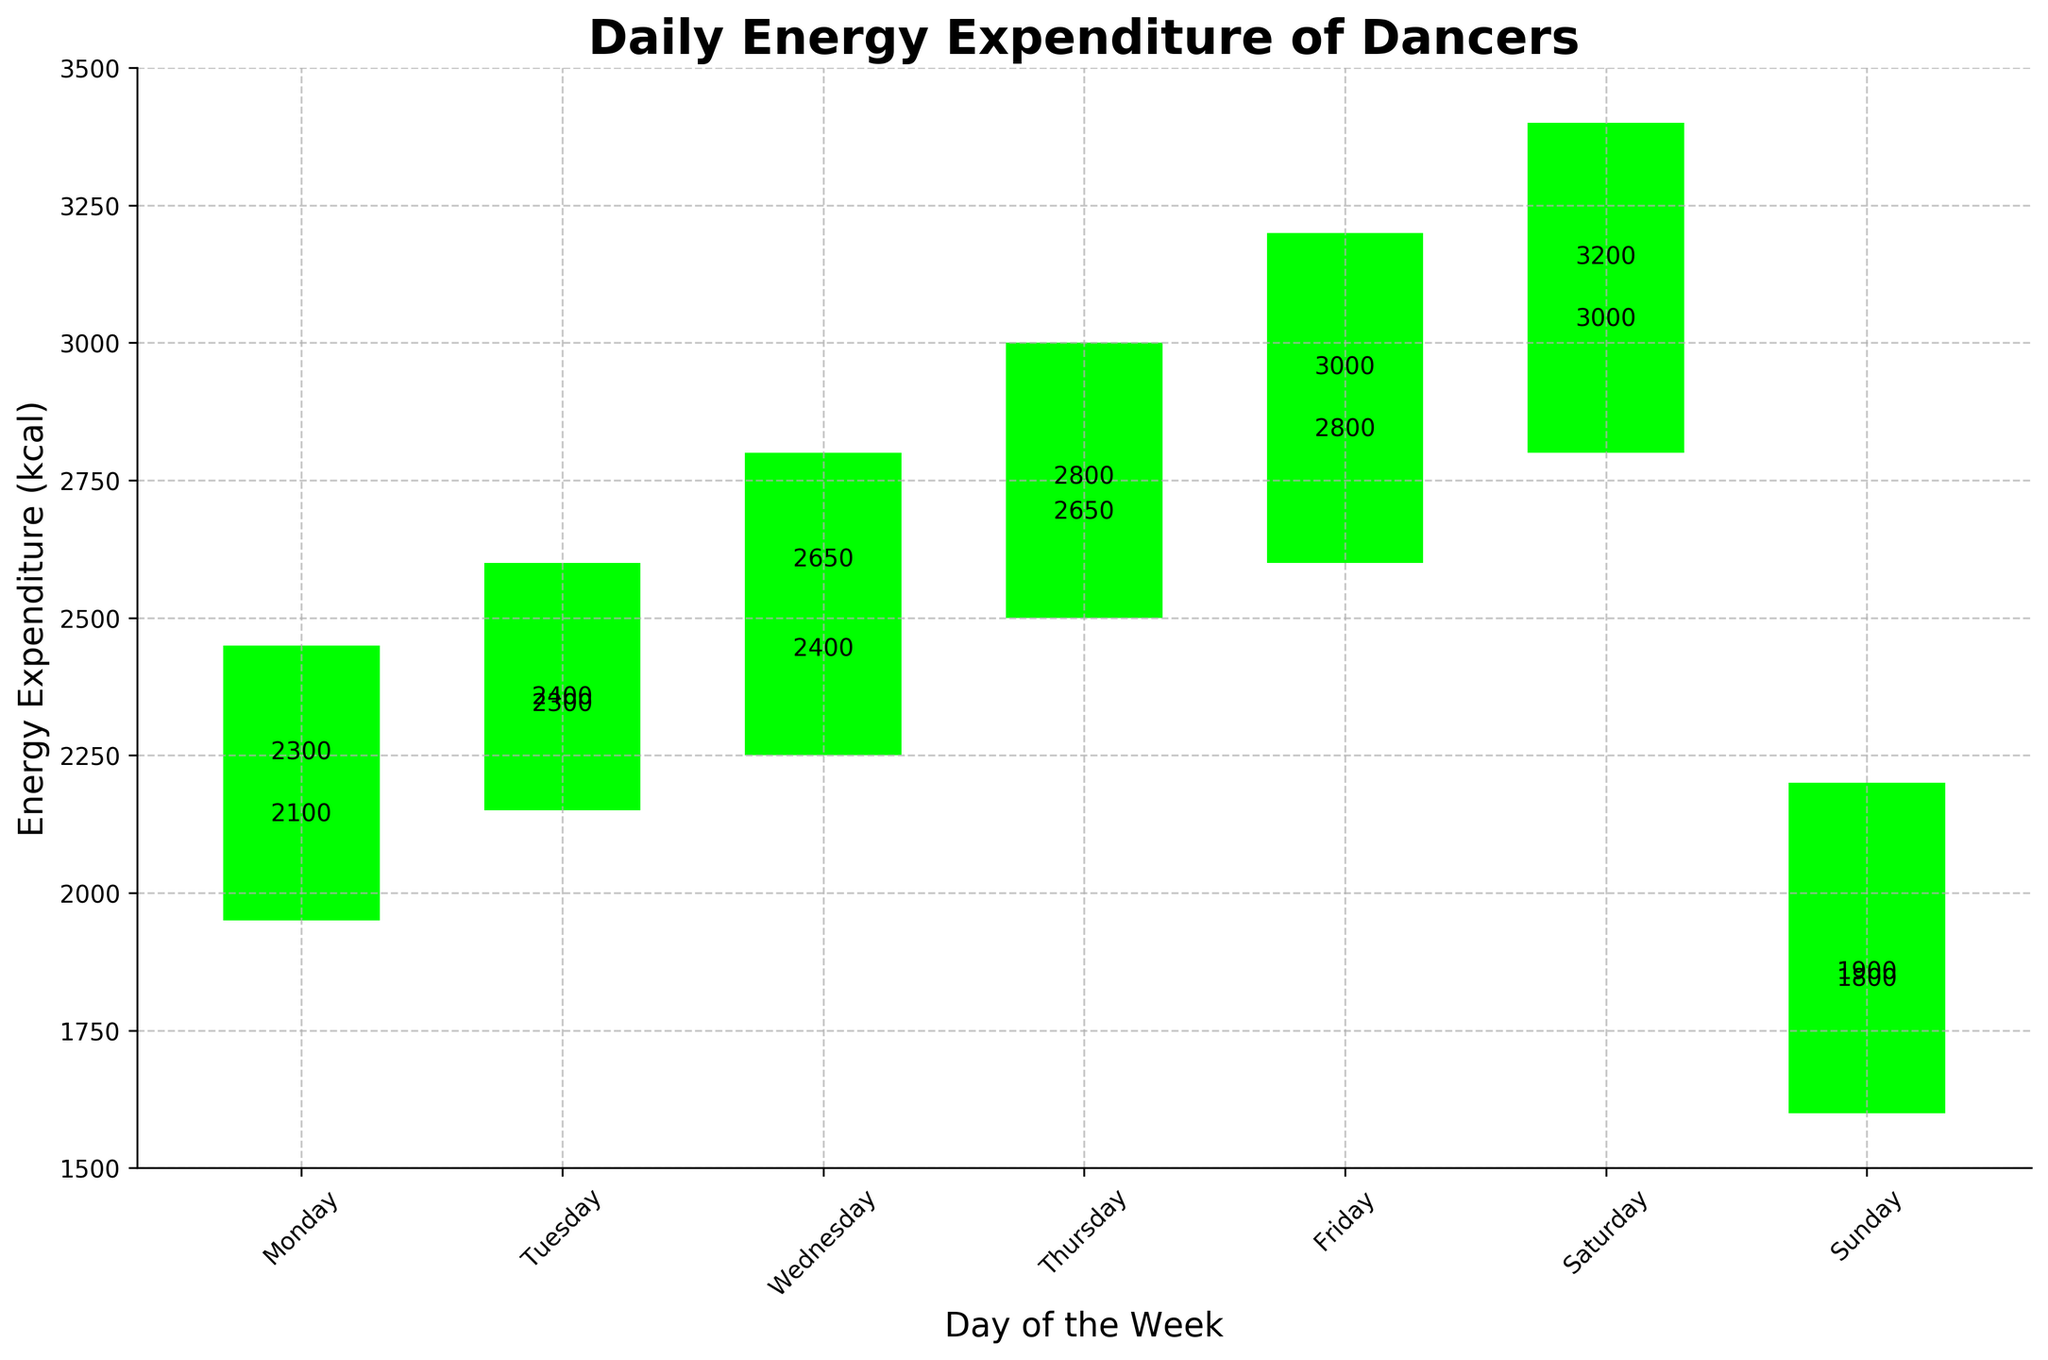What's the title of the chart? The title of the chart appears at the top and generally describes what the chart is about. In this case, it helps to understand the main focus of the data visualized.
Answer: Daily Energy Expenditure of Dancers On which day is the energy expenditure the highest by the close value? By observing the "Close" values for each day of the week, we look for the maximum number. In this case, the highest "Close" value is on Saturday.
Answer: Saturday What colors are used to indicate increases and decreases in energy expenditure? The colors in the chart indicate whether the dancers' energy expenditure increased or decreased from the "Open" to "Close" values for each day. Green is used for increases and red for decreases.
Answer: Green for increases, red for decreases Which day showed the largest range of energy expenditure? The range of energy expenditure for each day can be found by subtracting the "Low" value from the "High" value. Comparing these ranges across the week, the largest range is observed.
Answer: Saturday On how many days did the energy expenditure increase from open to close? By observing the green bars that indicate an increase from open to close, we count the number of days this occurred.
Answer: 6 days Which day had the lowest opening energy expenditure? By examining the "Open" values for each day of the week, we identify which day has the smallest value.
Answer: Sunday What is the average difference between the high and low values for the week? To find this, calculate the difference between the "High" and "Low" values for each day, sum these differences, and then divide by the number of days. Sum of differences = (500 + 450 + 550 + 500 + 400 + 400 + 400) = 3200. Average = 3200 / 7
Answer: ~457.14 kcal Which two consecutive days showed the greatest increase in energy expenditure from day to day? To find this, look at the "Close" values for each day and calculate the differences between consecutive days. Identify the largest difference. Thursday to Friday shows the greatest increase (3000 - 2800 = 200).
Answer: Thursday to Friday What was the energy expenditure range on Sunday? The range can be found by subtracting the lowest value ("Low") from the highest value ("High") on Sunday.
Answer: 600 kcal 